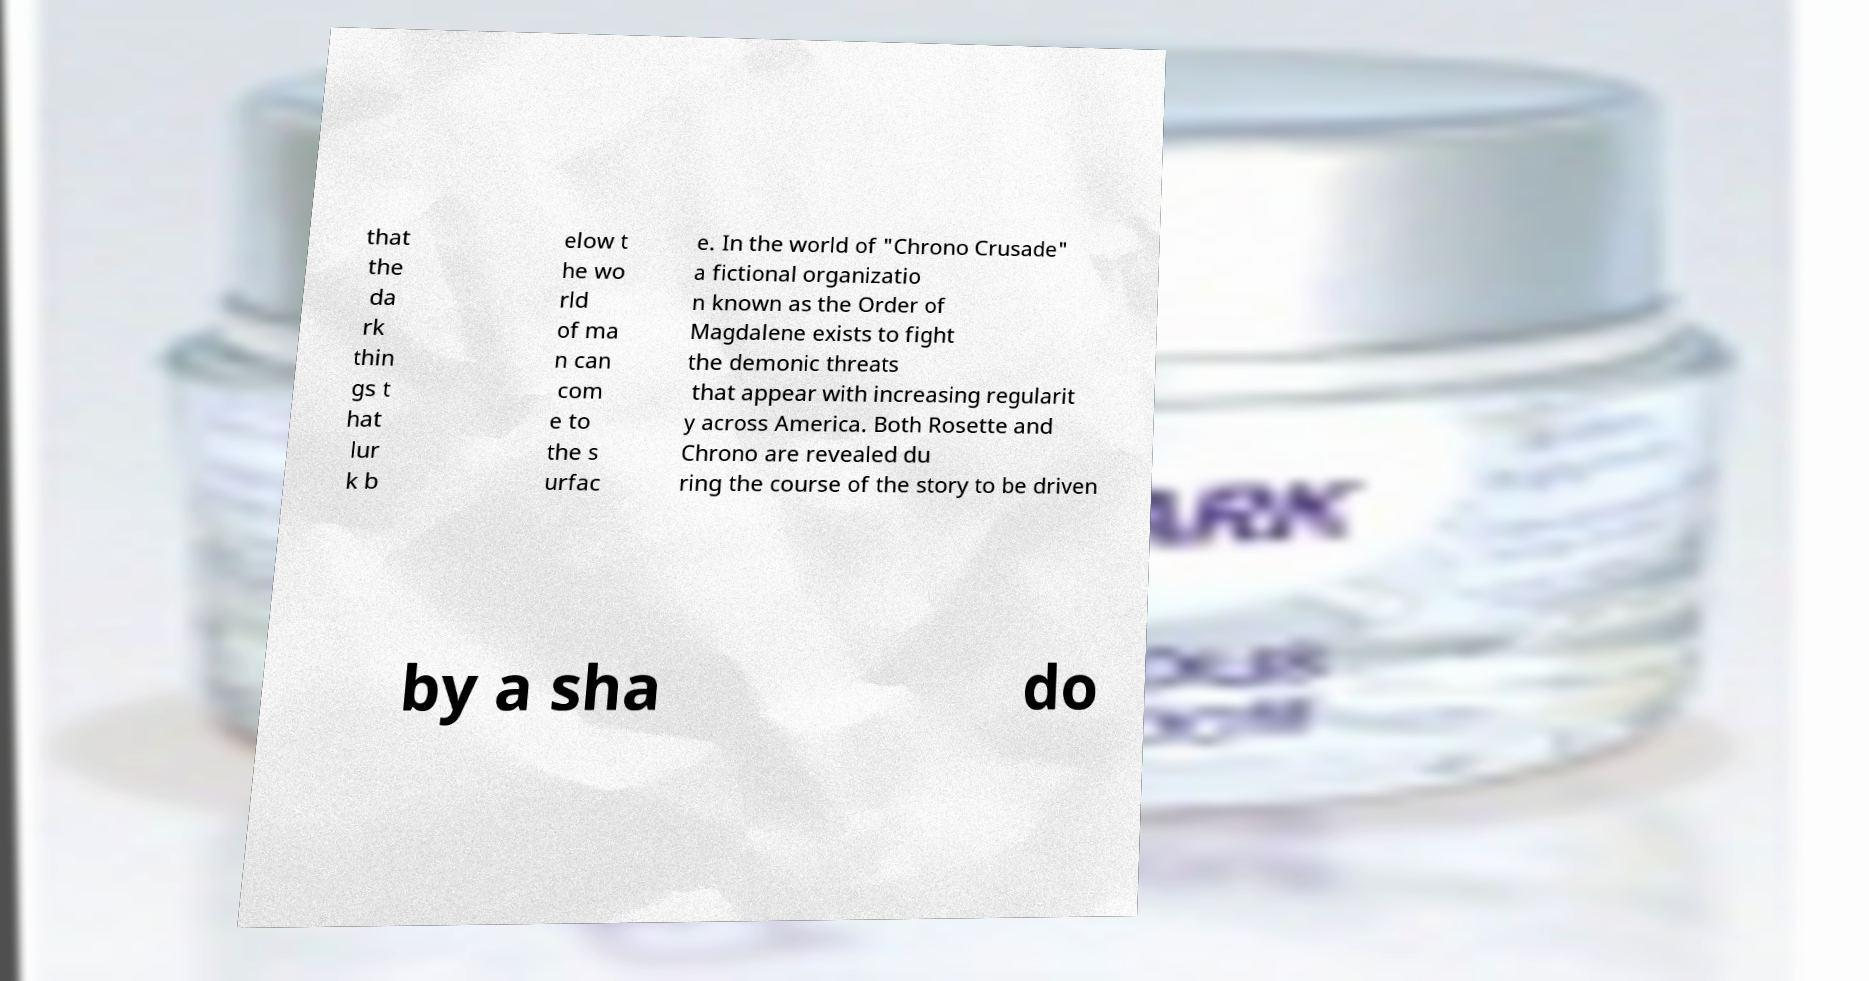Please read and relay the text visible in this image. What does it say? that the da rk thin gs t hat lur k b elow t he wo rld of ma n can com e to the s urfac e. In the world of "Chrono Crusade" a fictional organizatio n known as the Order of Magdalene exists to fight the demonic threats that appear with increasing regularit y across America. Both Rosette and Chrono are revealed du ring the course of the story to be driven by a sha do 